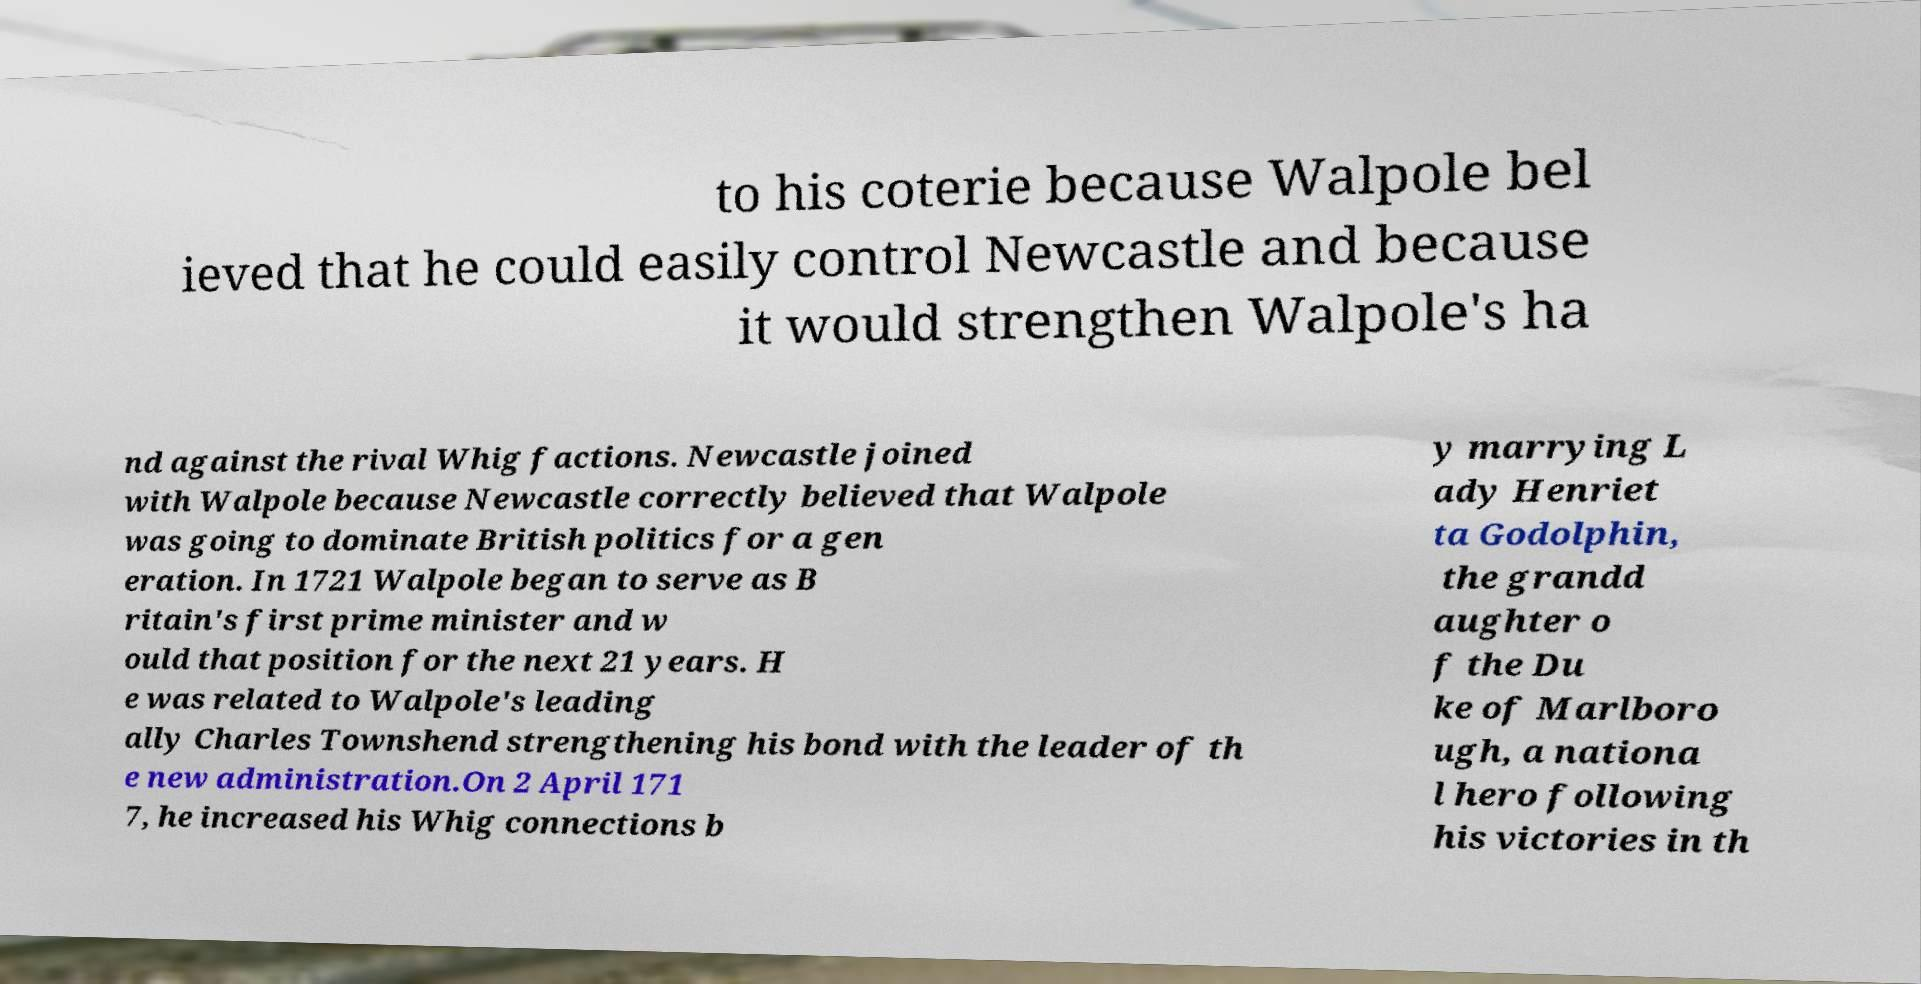Can you accurately transcribe the text from the provided image for me? to his coterie because Walpole bel ieved that he could easily control Newcastle and because it would strengthen Walpole's ha nd against the rival Whig factions. Newcastle joined with Walpole because Newcastle correctly believed that Walpole was going to dominate British politics for a gen eration. In 1721 Walpole began to serve as B ritain's first prime minister and w ould that position for the next 21 years. H e was related to Walpole's leading ally Charles Townshend strengthening his bond with the leader of th e new administration.On 2 April 171 7, he increased his Whig connections b y marrying L ady Henriet ta Godolphin, the grandd aughter o f the Du ke of Marlboro ugh, a nationa l hero following his victories in th 